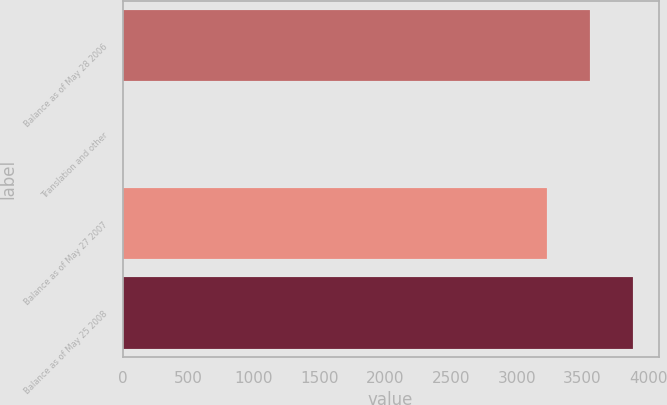Convert chart to OTSL. <chart><loc_0><loc_0><loc_500><loc_500><bar_chart><fcel>Balance as of May 28 2006<fcel>Translation and other<fcel>Balance as of May 27 2007<fcel>Balance as of May 25 2008<nl><fcel>3556.47<fcel>0.9<fcel>3228.4<fcel>3884.54<nl></chart> 